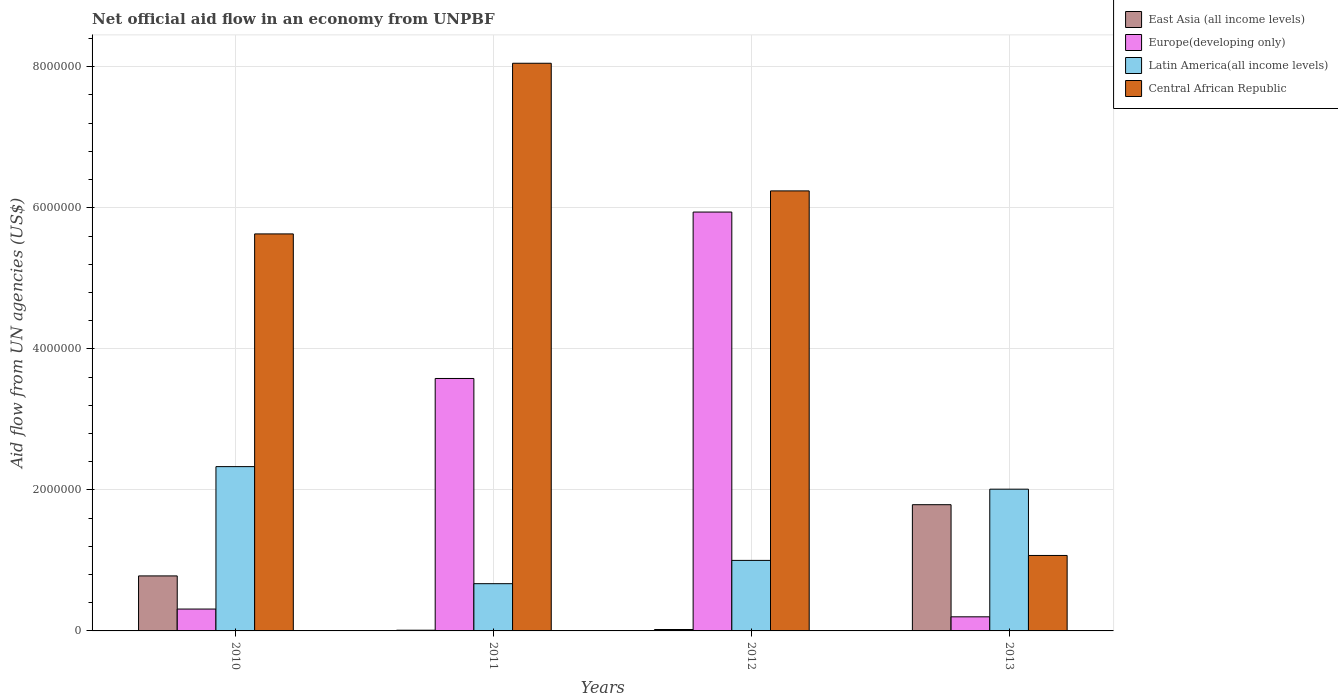Are the number of bars per tick equal to the number of legend labels?
Provide a succinct answer. Yes. What is the label of the 2nd group of bars from the left?
Your response must be concise. 2011. In how many cases, is the number of bars for a given year not equal to the number of legend labels?
Keep it short and to the point. 0. What is the net official aid flow in East Asia (all income levels) in 2013?
Your answer should be very brief. 1.79e+06. Across all years, what is the maximum net official aid flow in Latin America(all income levels)?
Offer a very short reply. 2.33e+06. Across all years, what is the minimum net official aid flow in Central African Republic?
Your answer should be very brief. 1.07e+06. What is the total net official aid flow in Central African Republic in the graph?
Offer a terse response. 2.10e+07. What is the difference between the net official aid flow in Central African Republic in 2010 and that in 2013?
Provide a succinct answer. 4.56e+06. What is the difference between the net official aid flow in Europe(developing only) in 2010 and the net official aid flow in Central African Republic in 2013?
Offer a terse response. -7.60e+05. What is the average net official aid flow in Central African Republic per year?
Provide a short and direct response. 5.25e+06. In the year 2013, what is the difference between the net official aid flow in Central African Republic and net official aid flow in Europe(developing only)?
Ensure brevity in your answer.  8.70e+05. In how many years, is the net official aid flow in Europe(developing only) greater than 800000 US$?
Your answer should be compact. 2. What is the ratio of the net official aid flow in Latin America(all income levels) in 2010 to that in 2012?
Provide a short and direct response. 2.33. Is the net official aid flow in Central African Republic in 2012 less than that in 2013?
Your answer should be very brief. No. Is the difference between the net official aid flow in Central African Republic in 2010 and 2011 greater than the difference between the net official aid flow in Europe(developing only) in 2010 and 2011?
Your answer should be compact. Yes. What is the difference between the highest and the second highest net official aid flow in Latin America(all income levels)?
Your answer should be very brief. 3.20e+05. What is the difference between the highest and the lowest net official aid flow in Central African Republic?
Offer a very short reply. 6.98e+06. In how many years, is the net official aid flow in Latin America(all income levels) greater than the average net official aid flow in Latin America(all income levels) taken over all years?
Make the answer very short. 2. What does the 2nd bar from the left in 2010 represents?
Keep it short and to the point. Europe(developing only). What does the 2nd bar from the right in 2010 represents?
Offer a very short reply. Latin America(all income levels). How many bars are there?
Your answer should be compact. 16. What is the difference between two consecutive major ticks on the Y-axis?
Provide a succinct answer. 2.00e+06. Are the values on the major ticks of Y-axis written in scientific E-notation?
Your answer should be compact. No. Where does the legend appear in the graph?
Ensure brevity in your answer.  Top right. What is the title of the graph?
Offer a terse response. Net official aid flow in an economy from UNPBF. Does "Dominican Republic" appear as one of the legend labels in the graph?
Give a very brief answer. No. What is the label or title of the Y-axis?
Provide a short and direct response. Aid flow from UN agencies (US$). What is the Aid flow from UN agencies (US$) of East Asia (all income levels) in 2010?
Provide a short and direct response. 7.80e+05. What is the Aid flow from UN agencies (US$) of Europe(developing only) in 2010?
Give a very brief answer. 3.10e+05. What is the Aid flow from UN agencies (US$) in Latin America(all income levels) in 2010?
Your answer should be very brief. 2.33e+06. What is the Aid flow from UN agencies (US$) in Central African Republic in 2010?
Provide a short and direct response. 5.63e+06. What is the Aid flow from UN agencies (US$) of Europe(developing only) in 2011?
Provide a short and direct response. 3.58e+06. What is the Aid flow from UN agencies (US$) in Latin America(all income levels) in 2011?
Your answer should be very brief. 6.70e+05. What is the Aid flow from UN agencies (US$) of Central African Republic in 2011?
Your answer should be very brief. 8.05e+06. What is the Aid flow from UN agencies (US$) in Europe(developing only) in 2012?
Ensure brevity in your answer.  5.94e+06. What is the Aid flow from UN agencies (US$) of Central African Republic in 2012?
Offer a terse response. 6.24e+06. What is the Aid flow from UN agencies (US$) in East Asia (all income levels) in 2013?
Your answer should be compact. 1.79e+06. What is the Aid flow from UN agencies (US$) of Europe(developing only) in 2013?
Your response must be concise. 2.00e+05. What is the Aid flow from UN agencies (US$) of Latin America(all income levels) in 2013?
Offer a very short reply. 2.01e+06. What is the Aid flow from UN agencies (US$) of Central African Republic in 2013?
Offer a very short reply. 1.07e+06. Across all years, what is the maximum Aid flow from UN agencies (US$) of East Asia (all income levels)?
Provide a succinct answer. 1.79e+06. Across all years, what is the maximum Aid flow from UN agencies (US$) of Europe(developing only)?
Ensure brevity in your answer.  5.94e+06. Across all years, what is the maximum Aid flow from UN agencies (US$) of Latin America(all income levels)?
Give a very brief answer. 2.33e+06. Across all years, what is the maximum Aid flow from UN agencies (US$) in Central African Republic?
Ensure brevity in your answer.  8.05e+06. Across all years, what is the minimum Aid flow from UN agencies (US$) in East Asia (all income levels)?
Ensure brevity in your answer.  10000. Across all years, what is the minimum Aid flow from UN agencies (US$) of Latin America(all income levels)?
Provide a succinct answer. 6.70e+05. Across all years, what is the minimum Aid flow from UN agencies (US$) of Central African Republic?
Ensure brevity in your answer.  1.07e+06. What is the total Aid flow from UN agencies (US$) of East Asia (all income levels) in the graph?
Your response must be concise. 2.60e+06. What is the total Aid flow from UN agencies (US$) in Europe(developing only) in the graph?
Provide a succinct answer. 1.00e+07. What is the total Aid flow from UN agencies (US$) of Latin America(all income levels) in the graph?
Keep it short and to the point. 6.01e+06. What is the total Aid flow from UN agencies (US$) in Central African Republic in the graph?
Provide a short and direct response. 2.10e+07. What is the difference between the Aid flow from UN agencies (US$) of East Asia (all income levels) in 2010 and that in 2011?
Make the answer very short. 7.70e+05. What is the difference between the Aid flow from UN agencies (US$) in Europe(developing only) in 2010 and that in 2011?
Make the answer very short. -3.27e+06. What is the difference between the Aid flow from UN agencies (US$) of Latin America(all income levels) in 2010 and that in 2011?
Keep it short and to the point. 1.66e+06. What is the difference between the Aid flow from UN agencies (US$) of Central African Republic in 2010 and that in 2011?
Offer a very short reply. -2.42e+06. What is the difference between the Aid flow from UN agencies (US$) of East Asia (all income levels) in 2010 and that in 2012?
Provide a succinct answer. 7.60e+05. What is the difference between the Aid flow from UN agencies (US$) in Europe(developing only) in 2010 and that in 2012?
Give a very brief answer. -5.63e+06. What is the difference between the Aid flow from UN agencies (US$) of Latin America(all income levels) in 2010 and that in 2012?
Give a very brief answer. 1.33e+06. What is the difference between the Aid flow from UN agencies (US$) in Central African Republic in 2010 and that in 2012?
Your answer should be compact. -6.10e+05. What is the difference between the Aid flow from UN agencies (US$) of East Asia (all income levels) in 2010 and that in 2013?
Give a very brief answer. -1.01e+06. What is the difference between the Aid flow from UN agencies (US$) of Latin America(all income levels) in 2010 and that in 2013?
Keep it short and to the point. 3.20e+05. What is the difference between the Aid flow from UN agencies (US$) in Central African Republic in 2010 and that in 2013?
Offer a very short reply. 4.56e+06. What is the difference between the Aid flow from UN agencies (US$) of Europe(developing only) in 2011 and that in 2012?
Offer a terse response. -2.36e+06. What is the difference between the Aid flow from UN agencies (US$) in Latin America(all income levels) in 2011 and that in 2012?
Offer a very short reply. -3.30e+05. What is the difference between the Aid flow from UN agencies (US$) of Central African Republic in 2011 and that in 2012?
Make the answer very short. 1.81e+06. What is the difference between the Aid flow from UN agencies (US$) in East Asia (all income levels) in 2011 and that in 2013?
Your answer should be compact. -1.78e+06. What is the difference between the Aid flow from UN agencies (US$) of Europe(developing only) in 2011 and that in 2013?
Your answer should be very brief. 3.38e+06. What is the difference between the Aid flow from UN agencies (US$) in Latin America(all income levels) in 2011 and that in 2013?
Offer a very short reply. -1.34e+06. What is the difference between the Aid flow from UN agencies (US$) of Central African Republic in 2011 and that in 2013?
Provide a succinct answer. 6.98e+06. What is the difference between the Aid flow from UN agencies (US$) in East Asia (all income levels) in 2012 and that in 2013?
Provide a succinct answer. -1.77e+06. What is the difference between the Aid flow from UN agencies (US$) of Europe(developing only) in 2012 and that in 2013?
Keep it short and to the point. 5.74e+06. What is the difference between the Aid flow from UN agencies (US$) in Latin America(all income levels) in 2012 and that in 2013?
Provide a short and direct response. -1.01e+06. What is the difference between the Aid flow from UN agencies (US$) in Central African Republic in 2012 and that in 2013?
Make the answer very short. 5.17e+06. What is the difference between the Aid flow from UN agencies (US$) of East Asia (all income levels) in 2010 and the Aid flow from UN agencies (US$) of Europe(developing only) in 2011?
Provide a succinct answer. -2.80e+06. What is the difference between the Aid flow from UN agencies (US$) in East Asia (all income levels) in 2010 and the Aid flow from UN agencies (US$) in Central African Republic in 2011?
Ensure brevity in your answer.  -7.27e+06. What is the difference between the Aid flow from UN agencies (US$) in Europe(developing only) in 2010 and the Aid flow from UN agencies (US$) in Latin America(all income levels) in 2011?
Offer a very short reply. -3.60e+05. What is the difference between the Aid flow from UN agencies (US$) in Europe(developing only) in 2010 and the Aid flow from UN agencies (US$) in Central African Republic in 2011?
Make the answer very short. -7.74e+06. What is the difference between the Aid flow from UN agencies (US$) in Latin America(all income levels) in 2010 and the Aid flow from UN agencies (US$) in Central African Republic in 2011?
Offer a terse response. -5.72e+06. What is the difference between the Aid flow from UN agencies (US$) in East Asia (all income levels) in 2010 and the Aid flow from UN agencies (US$) in Europe(developing only) in 2012?
Ensure brevity in your answer.  -5.16e+06. What is the difference between the Aid flow from UN agencies (US$) in East Asia (all income levels) in 2010 and the Aid flow from UN agencies (US$) in Central African Republic in 2012?
Keep it short and to the point. -5.46e+06. What is the difference between the Aid flow from UN agencies (US$) in Europe(developing only) in 2010 and the Aid flow from UN agencies (US$) in Latin America(all income levels) in 2012?
Offer a terse response. -6.90e+05. What is the difference between the Aid flow from UN agencies (US$) in Europe(developing only) in 2010 and the Aid flow from UN agencies (US$) in Central African Republic in 2012?
Your response must be concise. -5.93e+06. What is the difference between the Aid flow from UN agencies (US$) in Latin America(all income levels) in 2010 and the Aid flow from UN agencies (US$) in Central African Republic in 2012?
Offer a terse response. -3.91e+06. What is the difference between the Aid flow from UN agencies (US$) of East Asia (all income levels) in 2010 and the Aid flow from UN agencies (US$) of Europe(developing only) in 2013?
Ensure brevity in your answer.  5.80e+05. What is the difference between the Aid flow from UN agencies (US$) in East Asia (all income levels) in 2010 and the Aid flow from UN agencies (US$) in Latin America(all income levels) in 2013?
Your answer should be compact. -1.23e+06. What is the difference between the Aid flow from UN agencies (US$) of East Asia (all income levels) in 2010 and the Aid flow from UN agencies (US$) of Central African Republic in 2013?
Offer a very short reply. -2.90e+05. What is the difference between the Aid flow from UN agencies (US$) in Europe(developing only) in 2010 and the Aid flow from UN agencies (US$) in Latin America(all income levels) in 2013?
Ensure brevity in your answer.  -1.70e+06. What is the difference between the Aid flow from UN agencies (US$) in Europe(developing only) in 2010 and the Aid flow from UN agencies (US$) in Central African Republic in 2013?
Give a very brief answer. -7.60e+05. What is the difference between the Aid flow from UN agencies (US$) of Latin America(all income levels) in 2010 and the Aid flow from UN agencies (US$) of Central African Republic in 2013?
Make the answer very short. 1.26e+06. What is the difference between the Aid flow from UN agencies (US$) of East Asia (all income levels) in 2011 and the Aid flow from UN agencies (US$) of Europe(developing only) in 2012?
Ensure brevity in your answer.  -5.93e+06. What is the difference between the Aid flow from UN agencies (US$) in East Asia (all income levels) in 2011 and the Aid flow from UN agencies (US$) in Latin America(all income levels) in 2012?
Provide a succinct answer. -9.90e+05. What is the difference between the Aid flow from UN agencies (US$) of East Asia (all income levels) in 2011 and the Aid flow from UN agencies (US$) of Central African Republic in 2012?
Ensure brevity in your answer.  -6.23e+06. What is the difference between the Aid flow from UN agencies (US$) in Europe(developing only) in 2011 and the Aid flow from UN agencies (US$) in Latin America(all income levels) in 2012?
Ensure brevity in your answer.  2.58e+06. What is the difference between the Aid flow from UN agencies (US$) in Europe(developing only) in 2011 and the Aid flow from UN agencies (US$) in Central African Republic in 2012?
Provide a short and direct response. -2.66e+06. What is the difference between the Aid flow from UN agencies (US$) of Latin America(all income levels) in 2011 and the Aid flow from UN agencies (US$) of Central African Republic in 2012?
Provide a succinct answer. -5.57e+06. What is the difference between the Aid flow from UN agencies (US$) of East Asia (all income levels) in 2011 and the Aid flow from UN agencies (US$) of Latin America(all income levels) in 2013?
Offer a very short reply. -2.00e+06. What is the difference between the Aid flow from UN agencies (US$) in East Asia (all income levels) in 2011 and the Aid flow from UN agencies (US$) in Central African Republic in 2013?
Your answer should be very brief. -1.06e+06. What is the difference between the Aid flow from UN agencies (US$) of Europe(developing only) in 2011 and the Aid flow from UN agencies (US$) of Latin America(all income levels) in 2013?
Your response must be concise. 1.57e+06. What is the difference between the Aid flow from UN agencies (US$) of Europe(developing only) in 2011 and the Aid flow from UN agencies (US$) of Central African Republic in 2013?
Provide a short and direct response. 2.51e+06. What is the difference between the Aid flow from UN agencies (US$) of Latin America(all income levels) in 2011 and the Aid flow from UN agencies (US$) of Central African Republic in 2013?
Give a very brief answer. -4.00e+05. What is the difference between the Aid flow from UN agencies (US$) of East Asia (all income levels) in 2012 and the Aid flow from UN agencies (US$) of Latin America(all income levels) in 2013?
Offer a terse response. -1.99e+06. What is the difference between the Aid flow from UN agencies (US$) in East Asia (all income levels) in 2012 and the Aid flow from UN agencies (US$) in Central African Republic in 2013?
Keep it short and to the point. -1.05e+06. What is the difference between the Aid flow from UN agencies (US$) of Europe(developing only) in 2012 and the Aid flow from UN agencies (US$) of Latin America(all income levels) in 2013?
Provide a short and direct response. 3.93e+06. What is the difference between the Aid flow from UN agencies (US$) in Europe(developing only) in 2012 and the Aid flow from UN agencies (US$) in Central African Republic in 2013?
Your answer should be very brief. 4.87e+06. What is the average Aid flow from UN agencies (US$) of East Asia (all income levels) per year?
Give a very brief answer. 6.50e+05. What is the average Aid flow from UN agencies (US$) of Europe(developing only) per year?
Your answer should be compact. 2.51e+06. What is the average Aid flow from UN agencies (US$) of Latin America(all income levels) per year?
Your answer should be very brief. 1.50e+06. What is the average Aid flow from UN agencies (US$) of Central African Republic per year?
Offer a terse response. 5.25e+06. In the year 2010, what is the difference between the Aid flow from UN agencies (US$) in East Asia (all income levels) and Aid flow from UN agencies (US$) in Europe(developing only)?
Keep it short and to the point. 4.70e+05. In the year 2010, what is the difference between the Aid flow from UN agencies (US$) in East Asia (all income levels) and Aid flow from UN agencies (US$) in Latin America(all income levels)?
Your answer should be compact. -1.55e+06. In the year 2010, what is the difference between the Aid flow from UN agencies (US$) of East Asia (all income levels) and Aid flow from UN agencies (US$) of Central African Republic?
Give a very brief answer. -4.85e+06. In the year 2010, what is the difference between the Aid flow from UN agencies (US$) of Europe(developing only) and Aid flow from UN agencies (US$) of Latin America(all income levels)?
Offer a very short reply. -2.02e+06. In the year 2010, what is the difference between the Aid flow from UN agencies (US$) in Europe(developing only) and Aid flow from UN agencies (US$) in Central African Republic?
Your response must be concise. -5.32e+06. In the year 2010, what is the difference between the Aid flow from UN agencies (US$) of Latin America(all income levels) and Aid flow from UN agencies (US$) of Central African Republic?
Keep it short and to the point. -3.30e+06. In the year 2011, what is the difference between the Aid flow from UN agencies (US$) of East Asia (all income levels) and Aid flow from UN agencies (US$) of Europe(developing only)?
Give a very brief answer. -3.57e+06. In the year 2011, what is the difference between the Aid flow from UN agencies (US$) in East Asia (all income levels) and Aid flow from UN agencies (US$) in Latin America(all income levels)?
Your answer should be compact. -6.60e+05. In the year 2011, what is the difference between the Aid flow from UN agencies (US$) in East Asia (all income levels) and Aid flow from UN agencies (US$) in Central African Republic?
Provide a short and direct response. -8.04e+06. In the year 2011, what is the difference between the Aid flow from UN agencies (US$) of Europe(developing only) and Aid flow from UN agencies (US$) of Latin America(all income levels)?
Offer a terse response. 2.91e+06. In the year 2011, what is the difference between the Aid flow from UN agencies (US$) of Europe(developing only) and Aid flow from UN agencies (US$) of Central African Republic?
Your answer should be compact. -4.47e+06. In the year 2011, what is the difference between the Aid flow from UN agencies (US$) in Latin America(all income levels) and Aid flow from UN agencies (US$) in Central African Republic?
Offer a terse response. -7.38e+06. In the year 2012, what is the difference between the Aid flow from UN agencies (US$) in East Asia (all income levels) and Aid flow from UN agencies (US$) in Europe(developing only)?
Offer a very short reply. -5.92e+06. In the year 2012, what is the difference between the Aid flow from UN agencies (US$) of East Asia (all income levels) and Aid flow from UN agencies (US$) of Latin America(all income levels)?
Offer a very short reply. -9.80e+05. In the year 2012, what is the difference between the Aid flow from UN agencies (US$) in East Asia (all income levels) and Aid flow from UN agencies (US$) in Central African Republic?
Offer a very short reply. -6.22e+06. In the year 2012, what is the difference between the Aid flow from UN agencies (US$) in Europe(developing only) and Aid flow from UN agencies (US$) in Latin America(all income levels)?
Your response must be concise. 4.94e+06. In the year 2012, what is the difference between the Aid flow from UN agencies (US$) of Latin America(all income levels) and Aid flow from UN agencies (US$) of Central African Republic?
Ensure brevity in your answer.  -5.24e+06. In the year 2013, what is the difference between the Aid flow from UN agencies (US$) in East Asia (all income levels) and Aid flow from UN agencies (US$) in Europe(developing only)?
Ensure brevity in your answer.  1.59e+06. In the year 2013, what is the difference between the Aid flow from UN agencies (US$) of East Asia (all income levels) and Aid flow from UN agencies (US$) of Central African Republic?
Your response must be concise. 7.20e+05. In the year 2013, what is the difference between the Aid flow from UN agencies (US$) in Europe(developing only) and Aid flow from UN agencies (US$) in Latin America(all income levels)?
Your answer should be compact. -1.81e+06. In the year 2013, what is the difference between the Aid flow from UN agencies (US$) of Europe(developing only) and Aid flow from UN agencies (US$) of Central African Republic?
Provide a succinct answer. -8.70e+05. In the year 2013, what is the difference between the Aid flow from UN agencies (US$) in Latin America(all income levels) and Aid flow from UN agencies (US$) in Central African Republic?
Give a very brief answer. 9.40e+05. What is the ratio of the Aid flow from UN agencies (US$) in East Asia (all income levels) in 2010 to that in 2011?
Provide a succinct answer. 78. What is the ratio of the Aid flow from UN agencies (US$) in Europe(developing only) in 2010 to that in 2011?
Provide a short and direct response. 0.09. What is the ratio of the Aid flow from UN agencies (US$) of Latin America(all income levels) in 2010 to that in 2011?
Give a very brief answer. 3.48. What is the ratio of the Aid flow from UN agencies (US$) of Central African Republic in 2010 to that in 2011?
Give a very brief answer. 0.7. What is the ratio of the Aid flow from UN agencies (US$) in Europe(developing only) in 2010 to that in 2012?
Your response must be concise. 0.05. What is the ratio of the Aid flow from UN agencies (US$) of Latin America(all income levels) in 2010 to that in 2012?
Offer a terse response. 2.33. What is the ratio of the Aid flow from UN agencies (US$) in Central African Republic in 2010 to that in 2012?
Your answer should be very brief. 0.9. What is the ratio of the Aid flow from UN agencies (US$) in East Asia (all income levels) in 2010 to that in 2013?
Give a very brief answer. 0.44. What is the ratio of the Aid flow from UN agencies (US$) of Europe(developing only) in 2010 to that in 2013?
Make the answer very short. 1.55. What is the ratio of the Aid flow from UN agencies (US$) in Latin America(all income levels) in 2010 to that in 2013?
Keep it short and to the point. 1.16. What is the ratio of the Aid flow from UN agencies (US$) in Central African Republic in 2010 to that in 2013?
Your answer should be very brief. 5.26. What is the ratio of the Aid flow from UN agencies (US$) in Europe(developing only) in 2011 to that in 2012?
Offer a very short reply. 0.6. What is the ratio of the Aid flow from UN agencies (US$) in Latin America(all income levels) in 2011 to that in 2012?
Make the answer very short. 0.67. What is the ratio of the Aid flow from UN agencies (US$) in Central African Republic in 2011 to that in 2012?
Your response must be concise. 1.29. What is the ratio of the Aid flow from UN agencies (US$) in East Asia (all income levels) in 2011 to that in 2013?
Your answer should be compact. 0.01. What is the ratio of the Aid flow from UN agencies (US$) of Latin America(all income levels) in 2011 to that in 2013?
Ensure brevity in your answer.  0.33. What is the ratio of the Aid flow from UN agencies (US$) in Central African Republic in 2011 to that in 2013?
Keep it short and to the point. 7.52. What is the ratio of the Aid flow from UN agencies (US$) in East Asia (all income levels) in 2012 to that in 2013?
Offer a terse response. 0.01. What is the ratio of the Aid flow from UN agencies (US$) of Europe(developing only) in 2012 to that in 2013?
Your answer should be compact. 29.7. What is the ratio of the Aid flow from UN agencies (US$) in Latin America(all income levels) in 2012 to that in 2013?
Offer a terse response. 0.5. What is the ratio of the Aid flow from UN agencies (US$) in Central African Republic in 2012 to that in 2013?
Offer a very short reply. 5.83. What is the difference between the highest and the second highest Aid flow from UN agencies (US$) of East Asia (all income levels)?
Offer a terse response. 1.01e+06. What is the difference between the highest and the second highest Aid flow from UN agencies (US$) in Europe(developing only)?
Ensure brevity in your answer.  2.36e+06. What is the difference between the highest and the second highest Aid flow from UN agencies (US$) in Central African Republic?
Give a very brief answer. 1.81e+06. What is the difference between the highest and the lowest Aid flow from UN agencies (US$) of East Asia (all income levels)?
Your response must be concise. 1.78e+06. What is the difference between the highest and the lowest Aid flow from UN agencies (US$) of Europe(developing only)?
Provide a succinct answer. 5.74e+06. What is the difference between the highest and the lowest Aid flow from UN agencies (US$) in Latin America(all income levels)?
Your answer should be compact. 1.66e+06. What is the difference between the highest and the lowest Aid flow from UN agencies (US$) in Central African Republic?
Ensure brevity in your answer.  6.98e+06. 